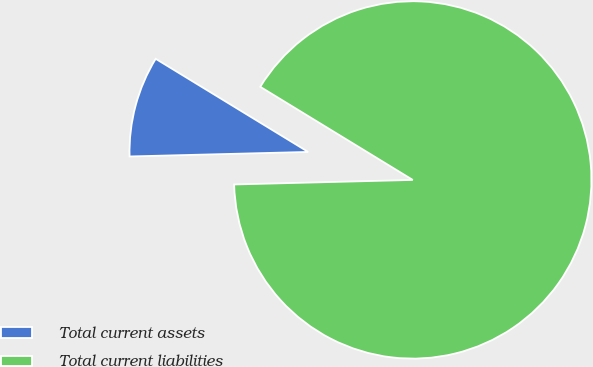<chart> <loc_0><loc_0><loc_500><loc_500><pie_chart><fcel>Total current assets<fcel>Total current liabilities<nl><fcel>9.13%<fcel>90.87%<nl></chart> 